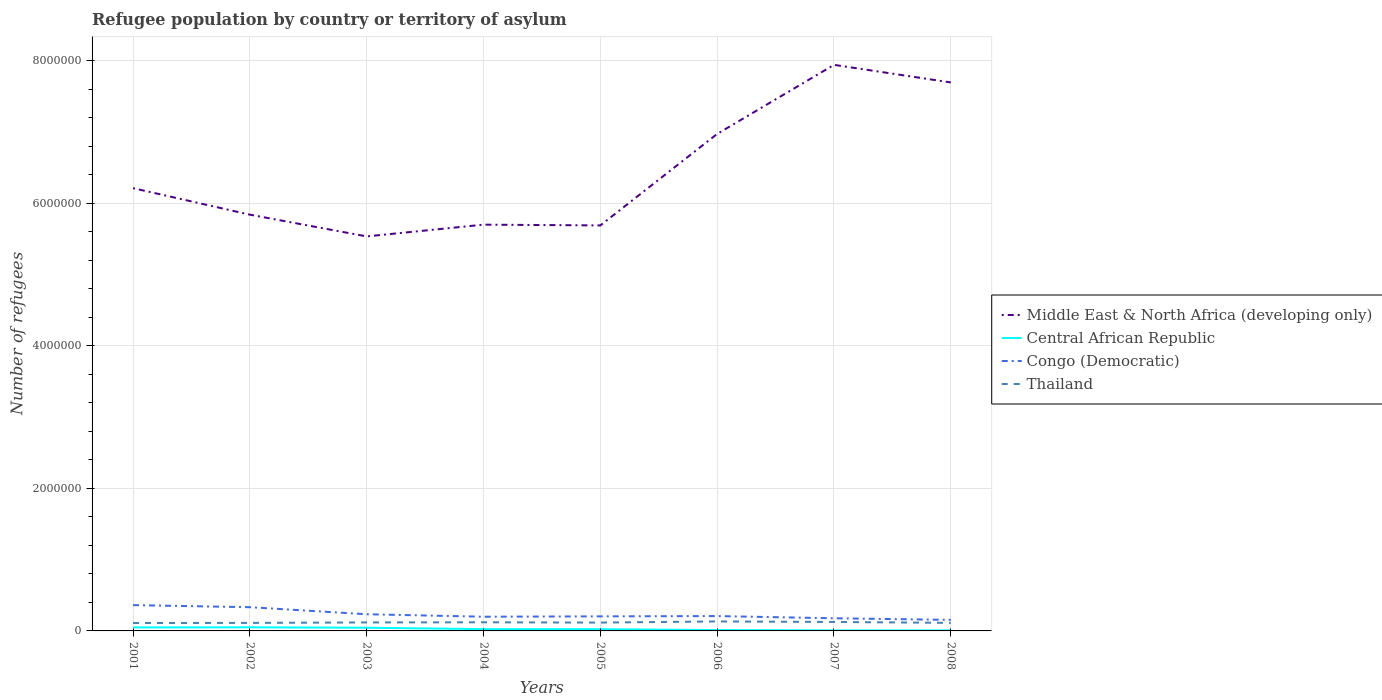How many different coloured lines are there?
Your answer should be very brief. 4. Does the line corresponding to Congo (Democratic) intersect with the line corresponding to Central African Republic?
Your answer should be very brief. No. Is the number of lines equal to the number of legend labels?
Provide a short and direct response. Yes. Across all years, what is the maximum number of refugees in Middle East & North Africa (developing only)?
Your response must be concise. 5.54e+06. In which year was the number of refugees in Congo (Democratic) maximum?
Your answer should be compact. 2008. What is the total number of refugees in Central African Republic in the graph?
Offer a very short reply. 3.73e+04. What is the difference between the highest and the second highest number of refugees in Central African Republic?
Your answer should be compact. 4.33e+04. What is the difference between the highest and the lowest number of refugees in Middle East & North Africa (developing only)?
Your answer should be compact. 3. Is the number of refugees in Middle East & North Africa (developing only) strictly greater than the number of refugees in Congo (Democratic) over the years?
Your response must be concise. No. How many lines are there?
Offer a very short reply. 4. What is the difference between two consecutive major ticks on the Y-axis?
Your answer should be very brief. 2.00e+06. Are the values on the major ticks of Y-axis written in scientific E-notation?
Your response must be concise. No. Does the graph contain any zero values?
Offer a terse response. No. Where does the legend appear in the graph?
Your answer should be very brief. Center right. What is the title of the graph?
Your response must be concise. Refugee population by country or territory of asylum. What is the label or title of the X-axis?
Provide a succinct answer. Years. What is the label or title of the Y-axis?
Offer a very short reply. Number of refugees. What is the Number of refugees in Middle East & North Africa (developing only) in 2001?
Provide a short and direct response. 6.21e+06. What is the Number of refugees in Central African Republic in 2001?
Your answer should be compact. 4.92e+04. What is the Number of refugees of Congo (Democratic) in 2001?
Your response must be concise. 3.62e+05. What is the Number of refugees of Thailand in 2001?
Your answer should be very brief. 1.11e+05. What is the Number of refugees in Middle East & North Africa (developing only) in 2002?
Your answer should be compact. 5.84e+06. What is the Number of refugees in Central African Republic in 2002?
Provide a succinct answer. 5.07e+04. What is the Number of refugees in Congo (Democratic) in 2002?
Offer a terse response. 3.33e+05. What is the Number of refugees in Thailand in 2002?
Offer a very short reply. 1.13e+05. What is the Number of refugees of Middle East & North Africa (developing only) in 2003?
Give a very brief answer. 5.54e+06. What is the Number of refugees in Central African Republic in 2003?
Make the answer very short. 4.48e+04. What is the Number of refugees of Congo (Democratic) in 2003?
Keep it short and to the point. 2.34e+05. What is the Number of refugees of Thailand in 2003?
Make the answer very short. 1.19e+05. What is the Number of refugees in Middle East & North Africa (developing only) in 2004?
Your answer should be very brief. 5.70e+06. What is the Number of refugees of Central African Republic in 2004?
Your answer should be compact. 2.50e+04. What is the Number of refugees in Congo (Democratic) in 2004?
Your response must be concise. 1.99e+05. What is the Number of refugees of Thailand in 2004?
Make the answer very short. 1.21e+05. What is the Number of refugees of Middle East & North Africa (developing only) in 2005?
Offer a terse response. 5.69e+06. What is the Number of refugees in Central African Republic in 2005?
Make the answer very short. 2.46e+04. What is the Number of refugees of Congo (Democratic) in 2005?
Provide a short and direct response. 2.04e+05. What is the Number of refugees of Thailand in 2005?
Provide a succinct answer. 1.17e+05. What is the Number of refugees of Middle East & North Africa (developing only) in 2006?
Offer a terse response. 6.97e+06. What is the Number of refugees in Central African Republic in 2006?
Give a very brief answer. 1.24e+04. What is the Number of refugees in Congo (Democratic) in 2006?
Ensure brevity in your answer.  2.08e+05. What is the Number of refugees in Thailand in 2006?
Give a very brief answer. 1.33e+05. What is the Number of refugees in Middle East & North Africa (developing only) in 2007?
Your answer should be compact. 7.94e+06. What is the Number of refugees in Central African Republic in 2007?
Provide a succinct answer. 7535. What is the Number of refugees of Congo (Democratic) in 2007?
Give a very brief answer. 1.77e+05. What is the Number of refugees in Thailand in 2007?
Your answer should be compact. 1.26e+05. What is the Number of refugees in Middle East & North Africa (developing only) in 2008?
Ensure brevity in your answer.  7.70e+06. What is the Number of refugees of Central African Republic in 2008?
Keep it short and to the point. 7429. What is the Number of refugees in Congo (Democratic) in 2008?
Your answer should be compact. 1.55e+05. What is the Number of refugees in Thailand in 2008?
Your answer should be compact. 1.13e+05. Across all years, what is the maximum Number of refugees in Middle East & North Africa (developing only)?
Make the answer very short. 7.94e+06. Across all years, what is the maximum Number of refugees in Central African Republic?
Offer a very short reply. 5.07e+04. Across all years, what is the maximum Number of refugees of Congo (Democratic)?
Offer a very short reply. 3.62e+05. Across all years, what is the maximum Number of refugees of Thailand?
Give a very brief answer. 1.33e+05. Across all years, what is the minimum Number of refugees of Middle East & North Africa (developing only)?
Provide a short and direct response. 5.54e+06. Across all years, what is the minimum Number of refugees of Central African Republic?
Make the answer very short. 7429. Across all years, what is the minimum Number of refugees in Congo (Democratic)?
Provide a short and direct response. 1.55e+05. Across all years, what is the minimum Number of refugees of Thailand?
Provide a short and direct response. 1.11e+05. What is the total Number of refugees of Middle East & North Africa (developing only) in the graph?
Ensure brevity in your answer.  5.16e+07. What is the total Number of refugees in Central African Republic in the graph?
Give a very brief answer. 2.22e+05. What is the total Number of refugees of Congo (Democratic) in the graph?
Provide a short and direct response. 1.87e+06. What is the total Number of refugees in Thailand in the graph?
Provide a short and direct response. 9.52e+05. What is the difference between the Number of refugees in Middle East & North Africa (developing only) in 2001 and that in 2002?
Provide a succinct answer. 3.72e+05. What is the difference between the Number of refugees in Central African Republic in 2001 and that in 2002?
Your answer should be very brief. -1486. What is the difference between the Number of refugees of Congo (Democratic) in 2001 and that in 2002?
Offer a very short reply. 2.90e+04. What is the difference between the Number of refugees of Thailand in 2001 and that in 2002?
Ensure brevity in your answer.  -1903. What is the difference between the Number of refugees in Middle East & North Africa (developing only) in 2001 and that in 2003?
Offer a terse response. 6.77e+05. What is the difference between the Number of refugees in Central African Republic in 2001 and that in 2003?
Make the answer very short. 4486. What is the difference between the Number of refugees of Congo (Democratic) in 2001 and that in 2003?
Your answer should be compact. 1.28e+05. What is the difference between the Number of refugees of Thailand in 2001 and that in 2003?
Provide a succinct answer. -8342. What is the difference between the Number of refugees of Middle East & North Africa (developing only) in 2001 and that in 2004?
Your answer should be compact. 5.12e+05. What is the difference between the Number of refugees of Central African Republic in 2001 and that in 2004?
Keep it short and to the point. 2.42e+04. What is the difference between the Number of refugees in Congo (Democratic) in 2001 and that in 2004?
Offer a terse response. 1.63e+05. What is the difference between the Number of refugees in Thailand in 2001 and that in 2004?
Provide a succinct answer. -1.04e+04. What is the difference between the Number of refugees of Middle East & North Africa (developing only) in 2001 and that in 2005?
Offer a terse response. 5.23e+05. What is the difference between the Number of refugees of Central African Republic in 2001 and that in 2005?
Your answer should be compact. 2.47e+04. What is the difference between the Number of refugees of Congo (Democratic) in 2001 and that in 2005?
Your answer should be very brief. 1.58e+05. What is the difference between the Number of refugees of Thailand in 2001 and that in 2005?
Make the answer very short. -6342. What is the difference between the Number of refugees of Middle East & North Africa (developing only) in 2001 and that in 2006?
Give a very brief answer. -7.61e+05. What is the difference between the Number of refugees of Central African Republic in 2001 and that in 2006?
Your response must be concise. 3.69e+04. What is the difference between the Number of refugees of Congo (Democratic) in 2001 and that in 2006?
Give a very brief answer. 1.54e+05. What is the difference between the Number of refugees of Thailand in 2001 and that in 2006?
Make the answer very short. -2.24e+04. What is the difference between the Number of refugees of Middle East & North Africa (developing only) in 2001 and that in 2007?
Keep it short and to the point. -1.73e+06. What is the difference between the Number of refugees of Central African Republic in 2001 and that in 2007?
Your answer should be very brief. 4.17e+04. What is the difference between the Number of refugees of Congo (Democratic) in 2001 and that in 2007?
Offer a terse response. 1.85e+05. What is the difference between the Number of refugees in Thailand in 2001 and that in 2007?
Make the answer very short. -1.49e+04. What is the difference between the Number of refugees of Middle East & North Africa (developing only) in 2001 and that in 2008?
Provide a short and direct response. -1.48e+06. What is the difference between the Number of refugees in Central African Republic in 2001 and that in 2008?
Make the answer very short. 4.18e+04. What is the difference between the Number of refugees in Congo (Democratic) in 2001 and that in 2008?
Your answer should be compact. 2.07e+05. What is the difference between the Number of refugees of Thailand in 2001 and that in 2008?
Your response must be concise. -2221. What is the difference between the Number of refugees in Middle East & North Africa (developing only) in 2002 and that in 2003?
Ensure brevity in your answer.  3.05e+05. What is the difference between the Number of refugees of Central African Republic in 2002 and that in 2003?
Provide a succinct answer. 5972. What is the difference between the Number of refugees of Congo (Democratic) in 2002 and that in 2003?
Give a very brief answer. 9.89e+04. What is the difference between the Number of refugees in Thailand in 2002 and that in 2003?
Offer a terse response. -6439. What is the difference between the Number of refugees of Middle East & North Africa (developing only) in 2002 and that in 2004?
Give a very brief answer. 1.40e+05. What is the difference between the Number of refugees of Central African Republic in 2002 and that in 2004?
Provide a short and direct response. 2.57e+04. What is the difference between the Number of refugees of Congo (Democratic) in 2002 and that in 2004?
Your response must be concise. 1.34e+05. What is the difference between the Number of refugees in Thailand in 2002 and that in 2004?
Ensure brevity in your answer.  -8525. What is the difference between the Number of refugees in Middle East & North Africa (developing only) in 2002 and that in 2005?
Make the answer very short. 1.51e+05. What is the difference between the Number of refugees of Central African Republic in 2002 and that in 2005?
Provide a succinct answer. 2.62e+04. What is the difference between the Number of refugees in Congo (Democratic) in 2002 and that in 2005?
Your answer should be very brief. 1.29e+05. What is the difference between the Number of refugees of Thailand in 2002 and that in 2005?
Offer a very short reply. -4439. What is the difference between the Number of refugees in Middle East & North Africa (developing only) in 2002 and that in 2006?
Your response must be concise. -1.13e+06. What is the difference between the Number of refugees in Central African Republic in 2002 and that in 2006?
Provide a short and direct response. 3.84e+04. What is the difference between the Number of refugees of Congo (Democratic) in 2002 and that in 2006?
Ensure brevity in your answer.  1.25e+05. What is the difference between the Number of refugees in Thailand in 2002 and that in 2006?
Provide a short and direct response. -2.05e+04. What is the difference between the Number of refugees of Middle East & North Africa (developing only) in 2002 and that in 2007?
Give a very brief answer. -2.10e+06. What is the difference between the Number of refugees in Central African Republic in 2002 and that in 2007?
Your response must be concise. 4.32e+04. What is the difference between the Number of refugees of Congo (Democratic) in 2002 and that in 2007?
Make the answer very short. 1.56e+05. What is the difference between the Number of refugees in Thailand in 2002 and that in 2007?
Provide a succinct answer. -1.30e+04. What is the difference between the Number of refugees in Middle East & North Africa (developing only) in 2002 and that in 2008?
Keep it short and to the point. -1.86e+06. What is the difference between the Number of refugees in Central African Republic in 2002 and that in 2008?
Give a very brief answer. 4.33e+04. What is the difference between the Number of refugees in Congo (Democratic) in 2002 and that in 2008?
Your answer should be very brief. 1.78e+05. What is the difference between the Number of refugees in Thailand in 2002 and that in 2008?
Your answer should be compact. -318. What is the difference between the Number of refugees of Middle East & North Africa (developing only) in 2003 and that in 2004?
Make the answer very short. -1.65e+05. What is the difference between the Number of refugees of Central African Republic in 2003 and that in 2004?
Your response must be concise. 1.97e+04. What is the difference between the Number of refugees in Congo (Democratic) in 2003 and that in 2004?
Your response must be concise. 3.47e+04. What is the difference between the Number of refugees of Thailand in 2003 and that in 2004?
Offer a very short reply. -2086. What is the difference between the Number of refugees in Middle East & North Africa (developing only) in 2003 and that in 2005?
Keep it short and to the point. -1.54e+05. What is the difference between the Number of refugees in Central African Republic in 2003 and that in 2005?
Ensure brevity in your answer.  2.02e+04. What is the difference between the Number of refugees in Congo (Democratic) in 2003 and that in 2005?
Your response must be concise. 2.97e+04. What is the difference between the Number of refugees of Thailand in 2003 and that in 2005?
Offer a very short reply. 2000. What is the difference between the Number of refugees of Middle East & North Africa (developing only) in 2003 and that in 2006?
Your response must be concise. -1.44e+06. What is the difference between the Number of refugees of Central African Republic in 2003 and that in 2006?
Offer a very short reply. 3.24e+04. What is the difference between the Number of refugees in Congo (Democratic) in 2003 and that in 2006?
Keep it short and to the point. 2.57e+04. What is the difference between the Number of refugees of Thailand in 2003 and that in 2006?
Ensure brevity in your answer.  -1.41e+04. What is the difference between the Number of refugees in Middle East & North Africa (developing only) in 2003 and that in 2007?
Your answer should be compact. -2.41e+06. What is the difference between the Number of refugees in Central African Republic in 2003 and that in 2007?
Your response must be concise. 3.72e+04. What is the difference between the Number of refugees in Congo (Democratic) in 2003 and that in 2007?
Provide a short and direct response. 5.66e+04. What is the difference between the Number of refugees in Thailand in 2003 and that in 2007?
Your answer should be very brief. -6590. What is the difference between the Number of refugees in Middle East & North Africa (developing only) in 2003 and that in 2008?
Give a very brief answer. -2.16e+06. What is the difference between the Number of refugees in Central African Republic in 2003 and that in 2008?
Ensure brevity in your answer.  3.73e+04. What is the difference between the Number of refugees in Congo (Democratic) in 2003 and that in 2008?
Your response must be concise. 7.89e+04. What is the difference between the Number of refugees of Thailand in 2003 and that in 2008?
Ensure brevity in your answer.  6121. What is the difference between the Number of refugees of Middle East & North Africa (developing only) in 2004 and that in 2005?
Ensure brevity in your answer.  1.07e+04. What is the difference between the Number of refugees of Central African Republic in 2004 and that in 2005?
Offer a very short reply. 451. What is the difference between the Number of refugees in Congo (Democratic) in 2004 and that in 2005?
Provide a short and direct response. -5018. What is the difference between the Number of refugees of Thailand in 2004 and that in 2005?
Your answer should be compact. 4086. What is the difference between the Number of refugees in Middle East & North Africa (developing only) in 2004 and that in 2006?
Make the answer very short. -1.27e+06. What is the difference between the Number of refugees of Central African Republic in 2004 and that in 2006?
Provide a succinct answer. 1.27e+04. What is the difference between the Number of refugees in Congo (Democratic) in 2004 and that in 2006?
Provide a short and direct response. -9048. What is the difference between the Number of refugees of Thailand in 2004 and that in 2006?
Give a very brief answer. -1.20e+04. What is the difference between the Number of refugees of Middle East & North Africa (developing only) in 2004 and that in 2007?
Provide a succinct answer. -2.24e+06. What is the difference between the Number of refugees in Central African Republic in 2004 and that in 2007?
Your answer should be very brief. 1.75e+04. What is the difference between the Number of refugees in Congo (Democratic) in 2004 and that in 2007?
Provide a succinct answer. 2.19e+04. What is the difference between the Number of refugees in Thailand in 2004 and that in 2007?
Offer a very short reply. -4504. What is the difference between the Number of refugees in Middle East & North Africa (developing only) in 2004 and that in 2008?
Keep it short and to the point. -2.00e+06. What is the difference between the Number of refugees in Central African Republic in 2004 and that in 2008?
Give a very brief answer. 1.76e+04. What is the difference between the Number of refugees in Congo (Democratic) in 2004 and that in 2008?
Your answer should be compact. 4.42e+04. What is the difference between the Number of refugees in Thailand in 2004 and that in 2008?
Offer a very short reply. 8207. What is the difference between the Number of refugees in Middle East & North Africa (developing only) in 2005 and that in 2006?
Keep it short and to the point. -1.28e+06. What is the difference between the Number of refugees in Central African Republic in 2005 and that in 2006?
Your answer should be compact. 1.22e+04. What is the difference between the Number of refugees of Congo (Democratic) in 2005 and that in 2006?
Ensure brevity in your answer.  -4030. What is the difference between the Number of refugees in Thailand in 2005 and that in 2006?
Your answer should be compact. -1.61e+04. What is the difference between the Number of refugees in Middle East & North Africa (developing only) in 2005 and that in 2007?
Give a very brief answer. -2.25e+06. What is the difference between the Number of refugees of Central African Republic in 2005 and that in 2007?
Your response must be concise. 1.70e+04. What is the difference between the Number of refugees of Congo (Democratic) in 2005 and that in 2007?
Provide a short and direct response. 2.70e+04. What is the difference between the Number of refugees of Thailand in 2005 and that in 2007?
Offer a very short reply. -8590. What is the difference between the Number of refugees of Middle East & North Africa (developing only) in 2005 and that in 2008?
Offer a very short reply. -2.01e+06. What is the difference between the Number of refugees in Central African Republic in 2005 and that in 2008?
Your response must be concise. 1.71e+04. What is the difference between the Number of refugees in Congo (Democratic) in 2005 and that in 2008?
Your response must be concise. 4.92e+04. What is the difference between the Number of refugees of Thailand in 2005 and that in 2008?
Give a very brief answer. 4121. What is the difference between the Number of refugees in Middle East & North Africa (developing only) in 2006 and that in 2007?
Provide a short and direct response. -9.69e+05. What is the difference between the Number of refugees of Central African Republic in 2006 and that in 2007?
Offer a terse response. 4822. What is the difference between the Number of refugees of Congo (Democratic) in 2006 and that in 2007?
Ensure brevity in your answer.  3.10e+04. What is the difference between the Number of refugees in Thailand in 2006 and that in 2007?
Give a very brief answer. 7474. What is the difference between the Number of refugees of Middle East & North Africa (developing only) in 2006 and that in 2008?
Keep it short and to the point. -7.22e+05. What is the difference between the Number of refugees in Central African Republic in 2006 and that in 2008?
Your answer should be compact. 4928. What is the difference between the Number of refugees in Congo (Democratic) in 2006 and that in 2008?
Your answer should be very brief. 5.32e+04. What is the difference between the Number of refugees in Thailand in 2006 and that in 2008?
Make the answer very short. 2.02e+04. What is the difference between the Number of refugees in Middle East & North Africa (developing only) in 2007 and that in 2008?
Your response must be concise. 2.47e+05. What is the difference between the Number of refugees of Central African Republic in 2007 and that in 2008?
Give a very brief answer. 106. What is the difference between the Number of refugees in Congo (Democratic) in 2007 and that in 2008?
Make the answer very short. 2.22e+04. What is the difference between the Number of refugees in Thailand in 2007 and that in 2008?
Ensure brevity in your answer.  1.27e+04. What is the difference between the Number of refugees of Middle East & North Africa (developing only) in 2001 and the Number of refugees of Central African Republic in 2002?
Your response must be concise. 6.16e+06. What is the difference between the Number of refugees of Middle East & North Africa (developing only) in 2001 and the Number of refugees of Congo (Democratic) in 2002?
Provide a short and direct response. 5.88e+06. What is the difference between the Number of refugees of Middle East & North Africa (developing only) in 2001 and the Number of refugees of Thailand in 2002?
Offer a very short reply. 6.10e+06. What is the difference between the Number of refugees of Central African Republic in 2001 and the Number of refugees of Congo (Democratic) in 2002?
Your response must be concise. -2.84e+05. What is the difference between the Number of refugees of Central African Republic in 2001 and the Number of refugees of Thailand in 2002?
Ensure brevity in your answer.  -6.34e+04. What is the difference between the Number of refugees in Congo (Democratic) in 2001 and the Number of refugees in Thailand in 2002?
Offer a very short reply. 2.49e+05. What is the difference between the Number of refugees of Middle East & North Africa (developing only) in 2001 and the Number of refugees of Central African Republic in 2003?
Keep it short and to the point. 6.17e+06. What is the difference between the Number of refugees in Middle East & North Africa (developing only) in 2001 and the Number of refugees in Congo (Democratic) in 2003?
Your answer should be compact. 5.98e+06. What is the difference between the Number of refugees of Middle East & North Africa (developing only) in 2001 and the Number of refugees of Thailand in 2003?
Provide a short and direct response. 6.09e+06. What is the difference between the Number of refugees in Central African Republic in 2001 and the Number of refugees in Congo (Democratic) in 2003?
Give a very brief answer. -1.85e+05. What is the difference between the Number of refugees of Central African Republic in 2001 and the Number of refugees of Thailand in 2003?
Offer a very short reply. -6.98e+04. What is the difference between the Number of refugees in Congo (Democratic) in 2001 and the Number of refugees in Thailand in 2003?
Give a very brief answer. 2.43e+05. What is the difference between the Number of refugees in Middle East & North Africa (developing only) in 2001 and the Number of refugees in Central African Republic in 2004?
Offer a terse response. 6.19e+06. What is the difference between the Number of refugees of Middle East & North Africa (developing only) in 2001 and the Number of refugees of Congo (Democratic) in 2004?
Offer a very short reply. 6.01e+06. What is the difference between the Number of refugees in Middle East & North Africa (developing only) in 2001 and the Number of refugees in Thailand in 2004?
Ensure brevity in your answer.  6.09e+06. What is the difference between the Number of refugees in Central African Republic in 2001 and the Number of refugees in Congo (Democratic) in 2004?
Ensure brevity in your answer.  -1.50e+05. What is the difference between the Number of refugees of Central African Republic in 2001 and the Number of refugees of Thailand in 2004?
Your answer should be very brief. -7.19e+04. What is the difference between the Number of refugees of Congo (Democratic) in 2001 and the Number of refugees of Thailand in 2004?
Your answer should be compact. 2.41e+05. What is the difference between the Number of refugees of Middle East & North Africa (developing only) in 2001 and the Number of refugees of Central African Republic in 2005?
Your answer should be compact. 6.19e+06. What is the difference between the Number of refugees of Middle East & North Africa (developing only) in 2001 and the Number of refugees of Congo (Democratic) in 2005?
Provide a succinct answer. 6.01e+06. What is the difference between the Number of refugees of Middle East & North Africa (developing only) in 2001 and the Number of refugees of Thailand in 2005?
Your answer should be very brief. 6.10e+06. What is the difference between the Number of refugees in Central African Republic in 2001 and the Number of refugees in Congo (Democratic) in 2005?
Give a very brief answer. -1.55e+05. What is the difference between the Number of refugees of Central African Republic in 2001 and the Number of refugees of Thailand in 2005?
Offer a very short reply. -6.78e+04. What is the difference between the Number of refugees of Congo (Democratic) in 2001 and the Number of refugees of Thailand in 2005?
Provide a short and direct response. 2.45e+05. What is the difference between the Number of refugees in Middle East & North Africa (developing only) in 2001 and the Number of refugees in Central African Republic in 2006?
Your response must be concise. 6.20e+06. What is the difference between the Number of refugees in Middle East & North Africa (developing only) in 2001 and the Number of refugees in Congo (Democratic) in 2006?
Your answer should be very brief. 6.00e+06. What is the difference between the Number of refugees of Middle East & North Africa (developing only) in 2001 and the Number of refugees of Thailand in 2006?
Keep it short and to the point. 6.08e+06. What is the difference between the Number of refugees of Central African Republic in 2001 and the Number of refugees of Congo (Democratic) in 2006?
Provide a short and direct response. -1.59e+05. What is the difference between the Number of refugees in Central African Republic in 2001 and the Number of refugees in Thailand in 2006?
Offer a terse response. -8.39e+04. What is the difference between the Number of refugees of Congo (Democratic) in 2001 and the Number of refugees of Thailand in 2006?
Your answer should be very brief. 2.29e+05. What is the difference between the Number of refugees in Middle East & North Africa (developing only) in 2001 and the Number of refugees in Central African Republic in 2007?
Give a very brief answer. 6.21e+06. What is the difference between the Number of refugees in Middle East & North Africa (developing only) in 2001 and the Number of refugees in Congo (Democratic) in 2007?
Provide a succinct answer. 6.04e+06. What is the difference between the Number of refugees in Middle East & North Africa (developing only) in 2001 and the Number of refugees in Thailand in 2007?
Ensure brevity in your answer.  6.09e+06. What is the difference between the Number of refugees of Central African Republic in 2001 and the Number of refugees of Congo (Democratic) in 2007?
Offer a terse response. -1.28e+05. What is the difference between the Number of refugees in Central African Republic in 2001 and the Number of refugees in Thailand in 2007?
Make the answer very short. -7.64e+04. What is the difference between the Number of refugees in Congo (Democratic) in 2001 and the Number of refugees in Thailand in 2007?
Keep it short and to the point. 2.36e+05. What is the difference between the Number of refugees of Middle East & North Africa (developing only) in 2001 and the Number of refugees of Central African Republic in 2008?
Offer a terse response. 6.21e+06. What is the difference between the Number of refugees of Middle East & North Africa (developing only) in 2001 and the Number of refugees of Congo (Democratic) in 2008?
Your response must be concise. 6.06e+06. What is the difference between the Number of refugees of Middle East & North Africa (developing only) in 2001 and the Number of refugees of Thailand in 2008?
Your response must be concise. 6.10e+06. What is the difference between the Number of refugees of Central African Republic in 2001 and the Number of refugees of Congo (Democratic) in 2008?
Ensure brevity in your answer.  -1.06e+05. What is the difference between the Number of refugees of Central African Republic in 2001 and the Number of refugees of Thailand in 2008?
Your response must be concise. -6.37e+04. What is the difference between the Number of refugees in Congo (Democratic) in 2001 and the Number of refugees in Thailand in 2008?
Ensure brevity in your answer.  2.49e+05. What is the difference between the Number of refugees of Middle East & North Africa (developing only) in 2002 and the Number of refugees of Central African Republic in 2003?
Offer a terse response. 5.80e+06. What is the difference between the Number of refugees of Middle East & North Africa (developing only) in 2002 and the Number of refugees of Congo (Democratic) in 2003?
Provide a succinct answer. 5.61e+06. What is the difference between the Number of refugees of Middle East & North Africa (developing only) in 2002 and the Number of refugees of Thailand in 2003?
Your answer should be very brief. 5.72e+06. What is the difference between the Number of refugees of Central African Republic in 2002 and the Number of refugees of Congo (Democratic) in 2003?
Offer a very short reply. -1.83e+05. What is the difference between the Number of refugees in Central African Republic in 2002 and the Number of refugees in Thailand in 2003?
Offer a very short reply. -6.83e+04. What is the difference between the Number of refugees of Congo (Democratic) in 2002 and the Number of refugees of Thailand in 2003?
Keep it short and to the point. 2.14e+05. What is the difference between the Number of refugees of Middle East & North Africa (developing only) in 2002 and the Number of refugees of Central African Republic in 2004?
Make the answer very short. 5.82e+06. What is the difference between the Number of refugees of Middle East & North Africa (developing only) in 2002 and the Number of refugees of Congo (Democratic) in 2004?
Your response must be concise. 5.64e+06. What is the difference between the Number of refugees in Middle East & North Africa (developing only) in 2002 and the Number of refugees in Thailand in 2004?
Provide a succinct answer. 5.72e+06. What is the difference between the Number of refugees in Central African Republic in 2002 and the Number of refugees in Congo (Democratic) in 2004?
Ensure brevity in your answer.  -1.49e+05. What is the difference between the Number of refugees in Central African Republic in 2002 and the Number of refugees in Thailand in 2004?
Give a very brief answer. -7.04e+04. What is the difference between the Number of refugees in Congo (Democratic) in 2002 and the Number of refugees in Thailand in 2004?
Your response must be concise. 2.12e+05. What is the difference between the Number of refugees of Middle East & North Africa (developing only) in 2002 and the Number of refugees of Central African Republic in 2005?
Your answer should be very brief. 5.82e+06. What is the difference between the Number of refugees of Middle East & North Africa (developing only) in 2002 and the Number of refugees of Congo (Democratic) in 2005?
Ensure brevity in your answer.  5.64e+06. What is the difference between the Number of refugees of Middle East & North Africa (developing only) in 2002 and the Number of refugees of Thailand in 2005?
Give a very brief answer. 5.72e+06. What is the difference between the Number of refugees of Central African Republic in 2002 and the Number of refugees of Congo (Democratic) in 2005?
Provide a succinct answer. -1.54e+05. What is the difference between the Number of refugees in Central African Republic in 2002 and the Number of refugees in Thailand in 2005?
Provide a succinct answer. -6.63e+04. What is the difference between the Number of refugees of Congo (Democratic) in 2002 and the Number of refugees of Thailand in 2005?
Your response must be concise. 2.16e+05. What is the difference between the Number of refugees in Middle East & North Africa (developing only) in 2002 and the Number of refugees in Central African Republic in 2006?
Keep it short and to the point. 5.83e+06. What is the difference between the Number of refugees in Middle East & North Africa (developing only) in 2002 and the Number of refugees in Congo (Democratic) in 2006?
Ensure brevity in your answer.  5.63e+06. What is the difference between the Number of refugees of Middle East & North Africa (developing only) in 2002 and the Number of refugees of Thailand in 2006?
Offer a terse response. 5.71e+06. What is the difference between the Number of refugees of Central African Republic in 2002 and the Number of refugees of Congo (Democratic) in 2006?
Offer a terse response. -1.58e+05. What is the difference between the Number of refugees in Central African Republic in 2002 and the Number of refugees in Thailand in 2006?
Give a very brief answer. -8.24e+04. What is the difference between the Number of refugees of Congo (Democratic) in 2002 and the Number of refugees of Thailand in 2006?
Ensure brevity in your answer.  2.00e+05. What is the difference between the Number of refugees in Middle East & North Africa (developing only) in 2002 and the Number of refugees in Central African Republic in 2007?
Your answer should be very brief. 5.83e+06. What is the difference between the Number of refugees of Middle East & North Africa (developing only) in 2002 and the Number of refugees of Congo (Democratic) in 2007?
Keep it short and to the point. 5.66e+06. What is the difference between the Number of refugees in Middle East & North Africa (developing only) in 2002 and the Number of refugees in Thailand in 2007?
Offer a very short reply. 5.72e+06. What is the difference between the Number of refugees of Central African Republic in 2002 and the Number of refugees of Congo (Democratic) in 2007?
Make the answer very short. -1.27e+05. What is the difference between the Number of refugees in Central African Republic in 2002 and the Number of refugees in Thailand in 2007?
Your answer should be very brief. -7.49e+04. What is the difference between the Number of refugees of Congo (Democratic) in 2002 and the Number of refugees of Thailand in 2007?
Ensure brevity in your answer.  2.07e+05. What is the difference between the Number of refugees in Middle East & North Africa (developing only) in 2002 and the Number of refugees in Central African Republic in 2008?
Ensure brevity in your answer.  5.83e+06. What is the difference between the Number of refugees in Middle East & North Africa (developing only) in 2002 and the Number of refugees in Congo (Democratic) in 2008?
Your response must be concise. 5.69e+06. What is the difference between the Number of refugees in Middle East & North Africa (developing only) in 2002 and the Number of refugees in Thailand in 2008?
Keep it short and to the point. 5.73e+06. What is the difference between the Number of refugees of Central African Republic in 2002 and the Number of refugees of Congo (Democratic) in 2008?
Ensure brevity in your answer.  -1.04e+05. What is the difference between the Number of refugees of Central African Republic in 2002 and the Number of refugees of Thailand in 2008?
Provide a short and direct response. -6.22e+04. What is the difference between the Number of refugees of Congo (Democratic) in 2002 and the Number of refugees of Thailand in 2008?
Offer a terse response. 2.20e+05. What is the difference between the Number of refugees of Middle East & North Africa (developing only) in 2003 and the Number of refugees of Central African Republic in 2004?
Offer a very short reply. 5.51e+06. What is the difference between the Number of refugees of Middle East & North Africa (developing only) in 2003 and the Number of refugees of Congo (Democratic) in 2004?
Your answer should be compact. 5.34e+06. What is the difference between the Number of refugees in Middle East & North Africa (developing only) in 2003 and the Number of refugees in Thailand in 2004?
Provide a succinct answer. 5.42e+06. What is the difference between the Number of refugees of Central African Republic in 2003 and the Number of refugees of Congo (Democratic) in 2004?
Make the answer very short. -1.55e+05. What is the difference between the Number of refugees in Central African Republic in 2003 and the Number of refugees in Thailand in 2004?
Make the answer very short. -7.64e+04. What is the difference between the Number of refugees in Congo (Democratic) in 2003 and the Number of refugees in Thailand in 2004?
Your answer should be very brief. 1.13e+05. What is the difference between the Number of refugees in Middle East & North Africa (developing only) in 2003 and the Number of refugees in Central African Republic in 2005?
Your answer should be very brief. 5.51e+06. What is the difference between the Number of refugees in Middle East & North Africa (developing only) in 2003 and the Number of refugees in Congo (Democratic) in 2005?
Your answer should be very brief. 5.33e+06. What is the difference between the Number of refugees of Middle East & North Africa (developing only) in 2003 and the Number of refugees of Thailand in 2005?
Keep it short and to the point. 5.42e+06. What is the difference between the Number of refugees of Central African Republic in 2003 and the Number of refugees of Congo (Democratic) in 2005?
Your answer should be very brief. -1.60e+05. What is the difference between the Number of refugees in Central African Republic in 2003 and the Number of refugees in Thailand in 2005?
Provide a short and direct response. -7.23e+04. What is the difference between the Number of refugees of Congo (Democratic) in 2003 and the Number of refugees of Thailand in 2005?
Your answer should be very brief. 1.17e+05. What is the difference between the Number of refugees of Middle East & North Africa (developing only) in 2003 and the Number of refugees of Central African Republic in 2006?
Provide a short and direct response. 5.52e+06. What is the difference between the Number of refugees in Middle East & North Africa (developing only) in 2003 and the Number of refugees in Congo (Democratic) in 2006?
Ensure brevity in your answer.  5.33e+06. What is the difference between the Number of refugees in Middle East & North Africa (developing only) in 2003 and the Number of refugees in Thailand in 2006?
Your response must be concise. 5.40e+06. What is the difference between the Number of refugees of Central African Republic in 2003 and the Number of refugees of Congo (Democratic) in 2006?
Keep it short and to the point. -1.64e+05. What is the difference between the Number of refugees in Central African Republic in 2003 and the Number of refugees in Thailand in 2006?
Provide a short and direct response. -8.84e+04. What is the difference between the Number of refugees in Congo (Democratic) in 2003 and the Number of refugees in Thailand in 2006?
Give a very brief answer. 1.01e+05. What is the difference between the Number of refugees in Middle East & North Africa (developing only) in 2003 and the Number of refugees in Central African Republic in 2007?
Make the answer very short. 5.53e+06. What is the difference between the Number of refugees in Middle East & North Africa (developing only) in 2003 and the Number of refugees in Congo (Democratic) in 2007?
Your answer should be very brief. 5.36e+06. What is the difference between the Number of refugees of Middle East & North Africa (developing only) in 2003 and the Number of refugees of Thailand in 2007?
Your answer should be compact. 5.41e+06. What is the difference between the Number of refugees in Central African Republic in 2003 and the Number of refugees in Congo (Democratic) in 2007?
Make the answer very short. -1.33e+05. What is the difference between the Number of refugees in Central African Republic in 2003 and the Number of refugees in Thailand in 2007?
Provide a short and direct response. -8.09e+04. What is the difference between the Number of refugees in Congo (Democratic) in 2003 and the Number of refugees in Thailand in 2007?
Provide a succinct answer. 1.08e+05. What is the difference between the Number of refugees in Middle East & North Africa (developing only) in 2003 and the Number of refugees in Central African Republic in 2008?
Ensure brevity in your answer.  5.53e+06. What is the difference between the Number of refugees in Middle East & North Africa (developing only) in 2003 and the Number of refugees in Congo (Democratic) in 2008?
Provide a succinct answer. 5.38e+06. What is the difference between the Number of refugees of Middle East & North Africa (developing only) in 2003 and the Number of refugees of Thailand in 2008?
Provide a succinct answer. 5.42e+06. What is the difference between the Number of refugees in Central African Republic in 2003 and the Number of refugees in Congo (Democratic) in 2008?
Give a very brief answer. -1.10e+05. What is the difference between the Number of refugees of Central African Republic in 2003 and the Number of refugees of Thailand in 2008?
Your answer should be compact. -6.82e+04. What is the difference between the Number of refugees in Congo (Democratic) in 2003 and the Number of refugees in Thailand in 2008?
Your answer should be very brief. 1.21e+05. What is the difference between the Number of refugees of Middle East & North Africa (developing only) in 2004 and the Number of refugees of Central African Republic in 2005?
Provide a succinct answer. 5.68e+06. What is the difference between the Number of refugees in Middle East & North Africa (developing only) in 2004 and the Number of refugees in Congo (Democratic) in 2005?
Your response must be concise. 5.50e+06. What is the difference between the Number of refugees of Middle East & North Africa (developing only) in 2004 and the Number of refugees of Thailand in 2005?
Provide a succinct answer. 5.58e+06. What is the difference between the Number of refugees of Central African Republic in 2004 and the Number of refugees of Congo (Democratic) in 2005?
Make the answer very short. -1.79e+05. What is the difference between the Number of refugees in Central African Republic in 2004 and the Number of refugees in Thailand in 2005?
Your answer should be very brief. -9.20e+04. What is the difference between the Number of refugees in Congo (Democratic) in 2004 and the Number of refugees in Thailand in 2005?
Offer a terse response. 8.23e+04. What is the difference between the Number of refugees in Middle East & North Africa (developing only) in 2004 and the Number of refugees in Central African Republic in 2006?
Offer a very short reply. 5.69e+06. What is the difference between the Number of refugees in Middle East & North Africa (developing only) in 2004 and the Number of refugees in Congo (Democratic) in 2006?
Offer a very short reply. 5.49e+06. What is the difference between the Number of refugees in Middle East & North Africa (developing only) in 2004 and the Number of refugees in Thailand in 2006?
Ensure brevity in your answer.  5.57e+06. What is the difference between the Number of refugees of Central African Republic in 2004 and the Number of refugees of Congo (Democratic) in 2006?
Your response must be concise. -1.83e+05. What is the difference between the Number of refugees in Central African Republic in 2004 and the Number of refugees in Thailand in 2006?
Provide a succinct answer. -1.08e+05. What is the difference between the Number of refugees in Congo (Democratic) in 2004 and the Number of refugees in Thailand in 2006?
Offer a terse response. 6.62e+04. What is the difference between the Number of refugees of Middle East & North Africa (developing only) in 2004 and the Number of refugees of Central African Republic in 2007?
Offer a terse response. 5.69e+06. What is the difference between the Number of refugees in Middle East & North Africa (developing only) in 2004 and the Number of refugees in Congo (Democratic) in 2007?
Ensure brevity in your answer.  5.52e+06. What is the difference between the Number of refugees of Middle East & North Africa (developing only) in 2004 and the Number of refugees of Thailand in 2007?
Make the answer very short. 5.58e+06. What is the difference between the Number of refugees of Central African Republic in 2004 and the Number of refugees of Congo (Democratic) in 2007?
Provide a succinct answer. -1.52e+05. What is the difference between the Number of refugees of Central African Republic in 2004 and the Number of refugees of Thailand in 2007?
Keep it short and to the point. -1.01e+05. What is the difference between the Number of refugees in Congo (Democratic) in 2004 and the Number of refugees in Thailand in 2007?
Give a very brief answer. 7.37e+04. What is the difference between the Number of refugees of Middle East & North Africa (developing only) in 2004 and the Number of refugees of Central African Republic in 2008?
Make the answer very short. 5.69e+06. What is the difference between the Number of refugees of Middle East & North Africa (developing only) in 2004 and the Number of refugees of Congo (Democratic) in 2008?
Offer a very short reply. 5.55e+06. What is the difference between the Number of refugees of Middle East & North Africa (developing only) in 2004 and the Number of refugees of Thailand in 2008?
Provide a short and direct response. 5.59e+06. What is the difference between the Number of refugees in Central African Republic in 2004 and the Number of refugees in Congo (Democratic) in 2008?
Ensure brevity in your answer.  -1.30e+05. What is the difference between the Number of refugees in Central African Republic in 2004 and the Number of refugees in Thailand in 2008?
Keep it short and to the point. -8.79e+04. What is the difference between the Number of refugees of Congo (Democratic) in 2004 and the Number of refugees of Thailand in 2008?
Offer a terse response. 8.64e+04. What is the difference between the Number of refugees of Middle East & North Africa (developing only) in 2005 and the Number of refugees of Central African Republic in 2006?
Your answer should be compact. 5.68e+06. What is the difference between the Number of refugees in Middle East & North Africa (developing only) in 2005 and the Number of refugees in Congo (Democratic) in 2006?
Your answer should be very brief. 5.48e+06. What is the difference between the Number of refugees of Middle East & North Africa (developing only) in 2005 and the Number of refugees of Thailand in 2006?
Keep it short and to the point. 5.56e+06. What is the difference between the Number of refugees of Central African Republic in 2005 and the Number of refugees of Congo (Democratic) in 2006?
Keep it short and to the point. -1.84e+05. What is the difference between the Number of refugees in Central African Republic in 2005 and the Number of refugees in Thailand in 2006?
Make the answer very short. -1.09e+05. What is the difference between the Number of refugees in Congo (Democratic) in 2005 and the Number of refugees in Thailand in 2006?
Give a very brief answer. 7.12e+04. What is the difference between the Number of refugees of Middle East & North Africa (developing only) in 2005 and the Number of refugees of Central African Republic in 2007?
Make the answer very short. 5.68e+06. What is the difference between the Number of refugees in Middle East & North Africa (developing only) in 2005 and the Number of refugees in Congo (Democratic) in 2007?
Your answer should be very brief. 5.51e+06. What is the difference between the Number of refugees of Middle East & North Africa (developing only) in 2005 and the Number of refugees of Thailand in 2007?
Keep it short and to the point. 5.56e+06. What is the difference between the Number of refugees in Central African Republic in 2005 and the Number of refugees in Congo (Democratic) in 2007?
Offer a terse response. -1.53e+05. What is the difference between the Number of refugees in Central African Republic in 2005 and the Number of refugees in Thailand in 2007?
Provide a succinct answer. -1.01e+05. What is the difference between the Number of refugees in Congo (Democratic) in 2005 and the Number of refugees in Thailand in 2007?
Offer a terse response. 7.87e+04. What is the difference between the Number of refugees of Middle East & North Africa (developing only) in 2005 and the Number of refugees of Central African Republic in 2008?
Offer a very short reply. 5.68e+06. What is the difference between the Number of refugees in Middle East & North Africa (developing only) in 2005 and the Number of refugees in Congo (Democratic) in 2008?
Your response must be concise. 5.54e+06. What is the difference between the Number of refugees in Middle East & North Africa (developing only) in 2005 and the Number of refugees in Thailand in 2008?
Keep it short and to the point. 5.58e+06. What is the difference between the Number of refugees in Central African Republic in 2005 and the Number of refugees in Congo (Democratic) in 2008?
Your answer should be very brief. -1.31e+05. What is the difference between the Number of refugees of Central African Republic in 2005 and the Number of refugees of Thailand in 2008?
Make the answer very short. -8.84e+04. What is the difference between the Number of refugees of Congo (Democratic) in 2005 and the Number of refugees of Thailand in 2008?
Provide a succinct answer. 9.14e+04. What is the difference between the Number of refugees of Middle East & North Africa (developing only) in 2006 and the Number of refugees of Central African Republic in 2007?
Your answer should be very brief. 6.97e+06. What is the difference between the Number of refugees of Middle East & North Africa (developing only) in 2006 and the Number of refugees of Congo (Democratic) in 2007?
Ensure brevity in your answer.  6.80e+06. What is the difference between the Number of refugees in Middle East & North Africa (developing only) in 2006 and the Number of refugees in Thailand in 2007?
Your answer should be compact. 6.85e+06. What is the difference between the Number of refugees in Central African Republic in 2006 and the Number of refugees in Congo (Democratic) in 2007?
Provide a succinct answer. -1.65e+05. What is the difference between the Number of refugees of Central African Republic in 2006 and the Number of refugees of Thailand in 2007?
Offer a very short reply. -1.13e+05. What is the difference between the Number of refugees in Congo (Democratic) in 2006 and the Number of refugees in Thailand in 2007?
Your response must be concise. 8.27e+04. What is the difference between the Number of refugees in Middle East & North Africa (developing only) in 2006 and the Number of refugees in Central African Republic in 2008?
Your answer should be compact. 6.97e+06. What is the difference between the Number of refugees of Middle East & North Africa (developing only) in 2006 and the Number of refugees of Congo (Democratic) in 2008?
Provide a succinct answer. 6.82e+06. What is the difference between the Number of refugees in Middle East & North Africa (developing only) in 2006 and the Number of refugees in Thailand in 2008?
Make the answer very short. 6.86e+06. What is the difference between the Number of refugees in Central African Republic in 2006 and the Number of refugees in Congo (Democratic) in 2008?
Provide a short and direct response. -1.43e+05. What is the difference between the Number of refugees of Central African Republic in 2006 and the Number of refugees of Thailand in 2008?
Your answer should be very brief. -1.01e+05. What is the difference between the Number of refugees in Congo (Democratic) in 2006 and the Number of refugees in Thailand in 2008?
Make the answer very short. 9.54e+04. What is the difference between the Number of refugees of Middle East & North Africa (developing only) in 2007 and the Number of refugees of Central African Republic in 2008?
Keep it short and to the point. 7.94e+06. What is the difference between the Number of refugees in Middle East & North Africa (developing only) in 2007 and the Number of refugees in Congo (Democratic) in 2008?
Offer a terse response. 7.79e+06. What is the difference between the Number of refugees in Middle East & North Africa (developing only) in 2007 and the Number of refugees in Thailand in 2008?
Make the answer very short. 7.83e+06. What is the difference between the Number of refugees in Central African Republic in 2007 and the Number of refugees in Congo (Democratic) in 2008?
Give a very brief answer. -1.48e+05. What is the difference between the Number of refugees of Central African Republic in 2007 and the Number of refugees of Thailand in 2008?
Offer a very short reply. -1.05e+05. What is the difference between the Number of refugees of Congo (Democratic) in 2007 and the Number of refugees of Thailand in 2008?
Your answer should be compact. 6.45e+04. What is the average Number of refugees of Middle East & North Africa (developing only) per year?
Provide a succinct answer. 6.45e+06. What is the average Number of refugees of Central African Republic per year?
Provide a short and direct response. 2.77e+04. What is the average Number of refugees in Congo (Democratic) per year?
Your answer should be compact. 2.34e+05. What is the average Number of refugees in Thailand per year?
Offer a very short reply. 1.19e+05. In the year 2001, what is the difference between the Number of refugees of Middle East & North Africa (developing only) and Number of refugees of Central African Republic?
Offer a terse response. 6.16e+06. In the year 2001, what is the difference between the Number of refugees of Middle East & North Africa (developing only) and Number of refugees of Congo (Democratic)?
Keep it short and to the point. 5.85e+06. In the year 2001, what is the difference between the Number of refugees of Middle East & North Africa (developing only) and Number of refugees of Thailand?
Offer a terse response. 6.10e+06. In the year 2001, what is the difference between the Number of refugees in Central African Republic and Number of refugees in Congo (Democratic)?
Give a very brief answer. -3.13e+05. In the year 2001, what is the difference between the Number of refugees of Central African Republic and Number of refugees of Thailand?
Your answer should be compact. -6.15e+04. In the year 2001, what is the difference between the Number of refugees in Congo (Democratic) and Number of refugees in Thailand?
Provide a succinct answer. 2.51e+05. In the year 2002, what is the difference between the Number of refugees of Middle East & North Africa (developing only) and Number of refugees of Central African Republic?
Offer a very short reply. 5.79e+06. In the year 2002, what is the difference between the Number of refugees in Middle East & North Africa (developing only) and Number of refugees in Congo (Democratic)?
Your response must be concise. 5.51e+06. In the year 2002, what is the difference between the Number of refugees of Middle East & North Africa (developing only) and Number of refugees of Thailand?
Provide a short and direct response. 5.73e+06. In the year 2002, what is the difference between the Number of refugees of Central African Republic and Number of refugees of Congo (Democratic)?
Offer a very short reply. -2.82e+05. In the year 2002, what is the difference between the Number of refugees of Central African Republic and Number of refugees of Thailand?
Your answer should be very brief. -6.19e+04. In the year 2002, what is the difference between the Number of refugees of Congo (Democratic) and Number of refugees of Thailand?
Your answer should be compact. 2.20e+05. In the year 2003, what is the difference between the Number of refugees in Middle East & North Africa (developing only) and Number of refugees in Central African Republic?
Your answer should be very brief. 5.49e+06. In the year 2003, what is the difference between the Number of refugees in Middle East & North Africa (developing only) and Number of refugees in Congo (Democratic)?
Provide a succinct answer. 5.30e+06. In the year 2003, what is the difference between the Number of refugees of Middle East & North Africa (developing only) and Number of refugees of Thailand?
Provide a short and direct response. 5.42e+06. In the year 2003, what is the difference between the Number of refugees of Central African Republic and Number of refugees of Congo (Democratic)?
Keep it short and to the point. -1.89e+05. In the year 2003, what is the difference between the Number of refugees of Central African Republic and Number of refugees of Thailand?
Make the answer very short. -7.43e+04. In the year 2003, what is the difference between the Number of refugees of Congo (Democratic) and Number of refugees of Thailand?
Your answer should be compact. 1.15e+05. In the year 2004, what is the difference between the Number of refugees in Middle East & North Africa (developing only) and Number of refugees in Central African Republic?
Offer a terse response. 5.68e+06. In the year 2004, what is the difference between the Number of refugees in Middle East & North Africa (developing only) and Number of refugees in Congo (Democratic)?
Provide a succinct answer. 5.50e+06. In the year 2004, what is the difference between the Number of refugees in Middle East & North Africa (developing only) and Number of refugees in Thailand?
Offer a very short reply. 5.58e+06. In the year 2004, what is the difference between the Number of refugees in Central African Republic and Number of refugees in Congo (Democratic)?
Keep it short and to the point. -1.74e+05. In the year 2004, what is the difference between the Number of refugees of Central African Republic and Number of refugees of Thailand?
Give a very brief answer. -9.61e+04. In the year 2004, what is the difference between the Number of refugees of Congo (Democratic) and Number of refugees of Thailand?
Your answer should be very brief. 7.82e+04. In the year 2005, what is the difference between the Number of refugees of Middle East & North Africa (developing only) and Number of refugees of Central African Republic?
Your answer should be very brief. 5.67e+06. In the year 2005, what is the difference between the Number of refugees of Middle East & North Africa (developing only) and Number of refugees of Congo (Democratic)?
Ensure brevity in your answer.  5.49e+06. In the year 2005, what is the difference between the Number of refugees in Middle East & North Africa (developing only) and Number of refugees in Thailand?
Ensure brevity in your answer.  5.57e+06. In the year 2005, what is the difference between the Number of refugees of Central African Republic and Number of refugees of Congo (Democratic)?
Keep it short and to the point. -1.80e+05. In the year 2005, what is the difference between the Number of refugees of Central African Republic and Number of refugees of Thailand?
Provide a succinct answer. -9.25e+04. In the year 2005, what is the difference between the Number of refugees in Congo (Democratic) and Number of refugees in Thailand?
Offer a terse response. 8.73e+04. In the year 2006, what is the difference between the Number of refugees in Middle East & North Africa (developing only) and Number of refugees in Central African Republic?
Your answer should be very brief. 6.96e+06. In the year 2006, what is the difference between the Number of refugees in Middle East & North Africa (developing only) and Number of refugees in Congo (Democratic)?
Offer a terse response. 6.77e+06. In the year 2006, what is the difference between the Number of refugees of Middle East & North Africa (developing only) and Number of refugees of Thailand?
Offer a terse response. 6.84e+06. In the year 2006, what is the difference between the Number of refugees of Central African Republic and Number of refugees of Congo (Democratic)?
Ensure brevity in your answer.  -1.96e+05. In the year 2006, what is the difference between the Number of refugees in Central African Republic and Number of refugees in Thailand?
Your answer should be very brief. -1.21e+05. In the year 2006, what is the difference between the Number of refugees in Congo (Democratic) and Number of refugees in Thailand?
Your answer should be compact. 7.53e+04. In the year 2007, what is the difference between the Number of refugees of Middle East & North Africa (developing only) and Number of refugees of Central African Republic?
Make the answer very short. 7.94e+06. In the year 2007, what is the difference between the Number of refugees of Middle East & North Africa (developing only) and Number of refugees of Congo (Democratic)?
Make the answer very short. 7.77e+06. In the year 2007, what is the difference between the Number of refugees of Middle East & North Africa (developing only) and Number of refugees of Thailand?
Your answer should be compact. 7.82e+06. In the year 2007, what is the difference between the Number of refugees of Central African Republic and Number of refugees of Congo (Democratic)?
Give a very brief answer. -1.70e+05. In the year 2007, what is the difference between the Number of refugees in Central African Republic and Number of refugees in Thailand?
Keep it short and to the point. -1.18e+05. In the year 2007, what is the difference between the Number of refugees of Congo (Democratic) and Number of refugees of Thailand?
Your answer should be very brief. 5.17e+04. In the year 2008, what is the difference between the Number of refugees in Middle East & North Africa (developing only) and Number of refugees in Central African Republic?
Provide a succinct answer. 7.69e+06. In the year 2008, what is the difference between the Number of refugees of Middle East & North Africa (developing only) and Number of refugees of Congo (Democratic)?
Provide a short and direct response. 7.54e+06. In the year 2008, what is the difference between the Number of refugees of Middle East & North Africa (developing only) and Number of refugees of Thailand?
Keep it short and to the point. 7.58e+06. In the year 2008, what is the difference between the Number of refugees in Central African Republic and Number of refugees in Congo (Democratic)?
Ensure brevity in your answer.  -1.48e+05. In the year 2008, what is the difference between the Number of refugees in Central African Republic and Number of refugees in Thailand?
Your answer should be compact. -1.06e+05. In the year 2008, what is the difference between the Number of refugees in Congo (Democratic) and Number of refugees in Thailand?
Provide a short and direct response. 4.22e+04. What is the ratio of the Number of refugees in Middle East & North Africa (developing only) in 2001 to that in 2002?
Make the answer very short. 1.06. What is the ratio of the Number of refugees of Central African Republic in 2001 to that in 2002?
Give a very brief answer. 0.97. What is the ratio of the Number of refugees of Congo (Democratic) in 2001 to that in 2002?
Keep it short and to the point. 1.09. What is the ratio of the Number of refugees of Thailand in 2001 to that in 2002?
Give a very brief answer. 0.98. What is the ratio of the Number of refugees in Middle East & North Africa (developing only) in 2001 to that in 2003?
Give a very brief answer. 1.12. What is the ratio of the Number of refugees in Central African Republic in 2001 to that in 2003?
Your answer should be compact. 1.1. What is the ratio of the Number of refugees in Congo (Democratic) in 2001 to that in 2003?
Give a very brief answer. 1.55. What is the ratio of the Number of refugees in Thailand in 2001 to that in 2003?
Your response must be concise. 0.93. What is the ratio of the Number of refugees of Middle East & North Africa (developing only) in 2001 to that in 2004?
Your response must be concise. 1.09. What is the ratio of the Number of refugees of Central African Republic in 2001 to that in 2004?
Make the answer very short. 1.97. What is the ratio of the Number of refugees in Congo (Democratic) in 2001 to that in 2004?
Make the answer very short. 1.82. What is the ratio of the Number of refugees in Thailand in 2001 to that in 2004?
Offer a terse response. 0.91. What is the ratio of the Number of refugees in Middle East & North Africa (developing only) in 2001 to that in 2005?
Offer a very short reply. 1.09. What is the ratio of the Number of refugees in Central African Republic in 2001 to that in 2005?
Provide a succinct answer. 2. What is the ratio of the Number of refugees in Congo (Democratic) in 2001 to that in 2005?
Provide a short and direct response. 1.77. What is the ratio of the Number of refugees of Thailand in 2001 to that in 2005?
Provide a succinct answer. 0.95. What is the ratio of the Number of refugees in Middle East & North Africa (developing only) in 2001 to that in 2006?
Your answer should be compact. 0.89. What is the ratio of the Number of refugees of Central African Republic in 2001 to that in 2006?
Ensure brevity in your answer.  3.98. What is the ratio of the Number of refugees of Congo (Democratic) in 2001 to that in 2006?
Your response must be concise. 1.74. What is the ratio of the Number of refugees in Thailand in 2001 to that in 2006?
Your answer should be very brief. 0.83. What is the ratio of the Number of refugees in Middle East & North Africa (developing only) in 2001 to that in 2007?
Keep it short and to the point. 0.78. What is the ratio of the Number of refugees of Central African Republic in 2001 to that in 2007?
Keep it short and to the point. 6.53. What is the ratio of the Number of refugees in Congo (Democratic) in 2001 to that in 2007?
Your answer should be very brief. 2.04. What is the ratio of the Number of refugees of Thailand in 2001 to that in 2007?
Make the answer very short. 0.88. What is the ratio of the Number of refugees of Middle East & North Africa (developing only) in 2001 to that in 2008?
Your answer should be compact. 0.81. What is the ratio of the Number of refugees of Central African Republic in 2001 to that in 2008?
Make the answer very short. 6.63. What is the ratio of the Number of refugees of Congo (Democratic) in 2001 to that in 2008?
Keep it short and to the point. 2.33. What is the ratio of the Number of refugees in Thailand in 2001 to that in 2008?
Your answer should be compact. 0.98. What is the ratio of the Number of refugees of Middle East & North Africa (developing only) in 2002 to that in 2003?
Give a very brief answer. 1.06. What is the ratio of the Number of refugees of Central African Republic in 2002 to that in 2003?
Make the answer very short. 1.13. What is the ratio of the Number of refugees in Congo (Democratic) in 2002 to that in 2003?
Offer a very short reply. 1.42. What is the ratio of the Number of refugees of Thailand in 2002 to that in 2003?
Give a very brief answer. 0.95. What is the ratio of the Number of refugees in Middle East & North Africa (developing only) in 2002 to that in 2004?
Offer a very short reply. 1.02. What is the ratio of the Number of refugees of Central African Republic in 2002 to that in 2004?
Provide a short and direct response. 2.03. What is the ratio of the Number of refugees in Congo (Democratic) in 2002 to that in 2004?
Offer a very short reply. 1.67. What is the ratio of the Number of refugees in Thailand in 2002 to that in 2004?
Offer a terse response. 0.93. What is the ratio of the Number of refugees in Middle East & North Africa (developing only) in 2002 to that in 2005?
Your answer should be very brief. 1.03. What is the ratio of the Number of refugees in Central African Republic in 2002 to that in 2005?
Offer a very short reply. 2.06. What is the ratio of the Number of refugees in Congo (Democratic) in 2002 to that in 2005?
Provide a short and direct response. 1.63. What is the ratio of the Number of refugees of Thailand in 2002 to that in 2005?
Give a very brief answer. 0.96. What is the ratio of the Number of refugees in Middle East & North Africa (developing only) in 2002 to that in 2006?
Make the answer very short. 0.84. What is the ratio of the Number of refugees of Central African Republic in 2002 to that in 2006?
Keep it short and to the point. 4.11. What is the ratio of the Number of refugees in Congo (Democratic) in 2002 to that in 2006?
Offer a very short reply. 1.6. What is the ratio of the Number of refugees in Thailand in 2002 to that in 2006?
Make the answer very short. 0.85. What is the ratio of the Number of refugees in Middle East & North Africa (developing only) in 2002 to that in 2007?
Your answer should be very brief. 0.74. What is the ratio of the Number of refugees of Central African Republic in 2002 to that in 2007?
Ensure brevity in your answer.  6.73. What is the ratio of the Number of refugees in Congo (Democratic) in 2002 to that in 2007?
Provide a short and direct response. 1.88. What is the ratio of the Number of refugees in Thailand in 2002 to that in 2007?
Ensure brevity in your answer.  0.9. What is the ratio of the Number of refugees in Middle East & North Africa (developing only) in 2002 to that in 2008?
Ensure brevity in your answer.  0.76. What is the ratio of the Number of refugees of Central African Republic in 2002 to that in 2008?
Offer a very short reply. 6.83. What is the ratio of the Number of refugees of Congo (Democratic) in 2002 to that in 2008?
Provide a short and direct response. 2.15. What is the ratio of the Number of refugees of Thailand in 2002 to that in 2008?
Your answer should be compact. 1. What is the ratio of the Number of refugees of Middle East & North Africa (developing only) in 2003 to that in 2004?
Ensure brevity in your answer.  0.97. What is the ratio of the Number of refugees of Central African Republic in 2003 to that in 2004?
Your answer should be compact. 1.79. What is the ratio of the Number of refugees of Congo (Democratic) in 2003 to that in 2004?
Give a very brief answer. 1.17. What is the ratio of the Number of refugees in Thailand in 2003 to that in 2004?
Your answer should be compact. 0.98. What is the ratio of the Number of refugees of Middle East & North Africa (developing only) in 2003 to that in 2005?
Offer a terse response. 0.97. What is the ratio of the Number of refugees in Central African Republic in 2003 to that in 2005?
Offer a very short reply. 1.82. What is the ratio of the Number of refugees in Congo (Democratic) in 2003 to that in 2005?
Give a very brief answer. 1.15. What is the ratio of the Number of refugees of Thailand in 2003 to that in 2005?
Your answer should be very brief. 1.02. What is the ratio of the Number of refugees in Middle East & North Africa (developing only) in 2003 to that in 2006?
Provide a succinct answer. 0.79. What is the ratio of the Number of refugees of Central African Republic in 2003 to that in 2006?
Provide a short and direct response. 3.62. What is the ratio of the Number of refugees of Congo (Democratic) in 2003 to that in 2006?
Your answer should be very brief. 1.12. What is the ratio of the Number of refugees of Thailand in 2003 to that in 2006?
Provide a short and direct response. 0.89. What is the ratio of the Number of refugees of Middle East & North Africa (developing only) in 2003 to that in 2007?
Your answer should be compact. 0.7. What is the ratio of the Number of refugees in Central African Republic in 2003 to that in 2007?
Ensure brevity in your answer.  5.94. What is the ratio of the Number of refugees of Congo (Democratic) in 2003 to that in 2007?
Your answer should be very brief. 1.32. What is the ratio of the Number of refugees in Thailand in 2003 to that in 2007?
Your answer should be compact. 0.95. What is the ratio of the Number of refugees in Middle East & North Africa (developing only) in 2003 to that in 2008?
Ensure brevity in your answer.  0.72. What is the ratio of the Number of refugees in Central African Republic in 2003 to that in 2008?
Your answer should be very brief. 6.02. What is the ratio of the Number of refugees in Congo (Democratic) in 2003 to that in 2008?
Keep it short and to the point. 1.51. What is the ratio of the Number of refugees in Thailand in 2003 to that in 2008?
Provide a short and direct response. 1.05. What is the ratio of the Number of refugees of Middle East & North Africa (developing only) in 2004 to that in 2005?
Provide a succinct answer. 1. What is the ratio of the Number of refugees of Central African Republic in 2004 to that in 2005?
Your response must be concise. 1.02. What is the ratio of the Number of refugees of Congo (Democratic) in 2004 to that in 2005?
Make the answer very short. 0.98. What is the ratio of the Number of refugees in Thailand in 2004 to that in 2005?
Keep it short and to the point. 1.03. What is the ratio of the Number of refugees of Middle East & North Africa (developing only) in 2004 to that in 2006?
Keep it short and to the point. 0.82. What is the ratio of the Number of refugees of Central African Republic in 2004 to that in 2006?
Make the answer very short. 2.02. What is the ratio of the Number of refugees of Congo (Democratic) in 2004 to that in 2006?
Your answer should be compact. 0.96. What is the ratio of the Number of refugees of Thailand in 2004 to that in 2006?
Make the answer very short. 0.91. What is the ratio of the Number of refugees of Middle East & North Africa (developing only) in 2004 to that in 2007?
Your answer should be compact. 0.72. What is the ratio of the Number of refugees in Central African Republic in 2004 to that in 2007?
Give a very brief answer. 3.32. What is the ratio of the Number of refugees in Congo (Democratic) in 2004 to that in 2007?
Offer a very short reply. 1.12. What is the ratio of the Number of refugees of Thailand in 2004 to that in 2007?
Offer a terse response. 0.96. What is the ratio of the Number of refugees in Middle East & North Africa (developing only) in 2004 to that in 2008?
Offer a terse response. 0.74. What is the ratio of the Number of refugees in Central African Republic in 2004 to that in 2008?
Keep it short and to the point. 3.37. What is the ratio of the Number of refugees in Congo (Democratic) in 2004 to that in 2008?
Your response must be concise. 1.28. What is the ratio of the Number of refugees in Thailand in 2004 to that in 2008?
Your response must be concise. 1.07. What is the ratio of the Number of refugees in Middle East & North Africa (developing only) in 2005 to that in 2006?
Make the answer very short. 0.82. What is the ratio of the Number of refugees in Central African Republic in 2005 to that in 2006?
Offer a very short reply. 1.99. What is the ratio of the Number of refugees in Congo (Democratic) in 2005 to that in 2006?
Your response must be concise. 0.98. What is the ratio of the Number of refugees in Thailand in 2005 to that in 2006?
Your answer should be compact. 0.88. What is the ratio of the Number of refugees in Middle East & North Africa (developing only) in 2005 to that in 2007?
Ensure brevity in your answer.  0.72. What is the ratio of the Number of refugees in Central African Republic in 2005 to that in 2007?
Your answer should be compact. 3.26. What is the ratio of the Number of refugees of Congo (Democratic) in 2005 to that in 2007?
Provide a succinct answer. 1.15. What is the ratio of the Number of refugees of Thailand in 2005 to that in 2007?
Offer a very short reply. 0.93. What is the ratio of the Number of refugees of Middle East & North Africa (developing only) in 2005 to that in 2008?
Keep it short and to the point. 0.74. What is the ratio of the Number of refugees in Central African Republic in 2005 to that in 2008?
Ensure brevity in your answer.  3.31. What is the ratio of the Number of refugees of Congo (Democratic) in 2005 to that in 2008?
Give a very brief answer. 1.32. What is the ratio of the Number of refugees of Thailand in 2005 to that in 2008?
Make the answer very short. 1.04. What is the ratio of the Number of refugees of Middle East & North Africa (developing only) in 2006 to that in 2007?
Your answer should be compact. 0.88. What is the ratio of the Number of refugees in Central African Republic in 2006 to that in 2007?
Your answer should be very brief. 1.64. What is the ratio of the Number of refugees in Congo (Democratic) in 2006 to that in 2007?
Offer a terse response. 1.17. What is the ratio of the Number of refugees of Thailand in 2006 to that in 2007?
Provide a succinct answer. 1.06. What is the ratio of the Number of refugees of Middle East & North Africa (developing only) in 2006 to that in 2008?
Give a very brief answer. 0.91. What is the ratio of the Number of refugees of Central African Republic in 2006 to that in 2008?
Offer a terse response. 1.66. What is the ratio of the Number of refugees of Congo (Democratic) in 2006 to that in 2008?
Your answer should be compact. 1.34. What is the ratio of the Number of refugees of Thailand in 2006 to that in 2008?
Keep it short and to the point. 1.18. What is the ratio of the Number of refugees of Middle East & North Africa (developing only) in 2007 to that in 2008?
Give a very brief answer. 1.03. What is the ratio of the Number of refugees in Central African Republic in 2007 to that in 2008?
Ensure brevity in your answer.  1.01. What is the ratio of the Number of refugees of Congo (Democratic) in 2007 to that in 2008?
Ensure brevity in your answer.  1.14. What is the ratio of the Number of refugees in Thailand in 2007 to that in 2008?
Offer a very short reply. 1.11. What is the difference between the highest and the second highest Number of refugees in Middle East & North Africa (developing only)?
Provide a succinct answer. 2.47e+05. What is the difference between the highest and the second highest Number of refugees in Central African Republic?
Provide a short and direct response. 1486. What is the difference between the highest and the second highest Number of refugees in Congo (Democratic)?
Keep it short and to the point. 2.90e+04. What is the difference between the highest and the second highest Number of refugees of Thailand?
Make the answer very short. 7474. What is the difference between the highest and the lowest Number of refugees in Middle East & North Africa (developing only)?
Keep it short and to the point. 2.41e+06. What is the difference between the highest and the lowest Number of refugees in Central African Republic?
Give a very brief answer. 4.33e+04. What is the difference between the highest and the lowest Number of refugees in Congo (Democratic)?
Keep it short and to the point. 2.07e+05. What is the difference between the highest and the lowest Number of refugees in Thailand?
Your answer should be very brief. 2.24e+04. 